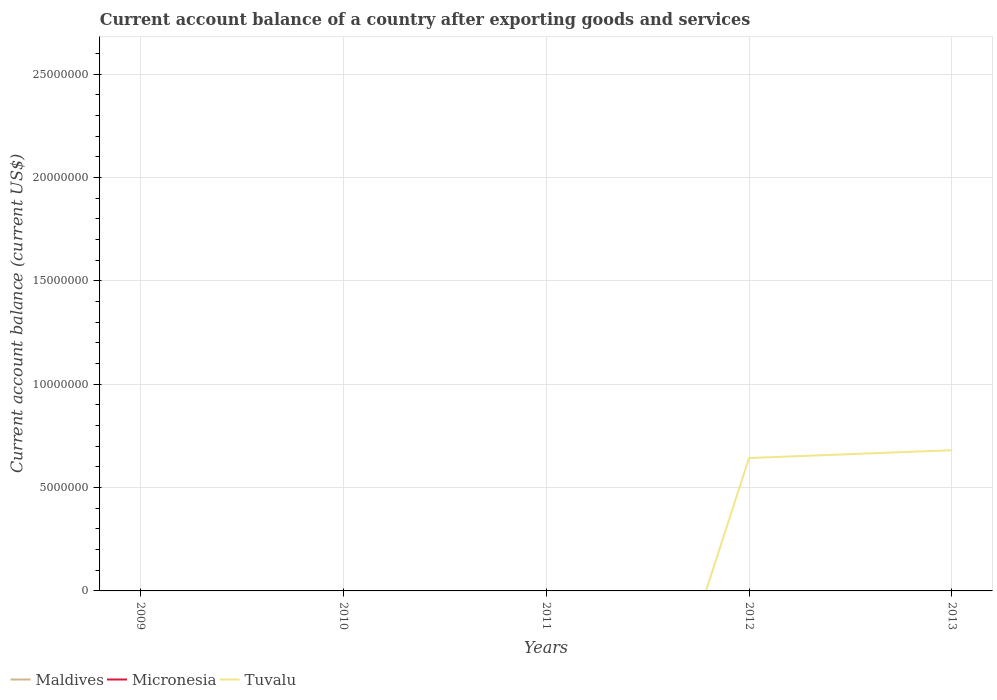What is the difference between the highest and the second highest account balance in Tuvalu?
Your answer should be compact. 6.81e+06. Is the account balance in Tuvalu strictly greater than the account balance in Maldives over the years?
Offer a terse response. No. How many lines are there?
Offer a very short reply. 1. Are the values on the major ticks of Y-axis written in scientific E-notation?
Your answer should be compact. No. Does the graph contain any zero values?
Your response must be concise. Yes. Does the graph contain grids?
Offer a very short reply. Yes. How are the legend labels stacked?
Offer a terse response. Horizontal. What is the title of the graph?
Keep it short and to the point. Current account balance of a country after exporting goods and services. Does "Cameroon" appear as one of the legend labels in the graph?
Your answer should be very brief. No. What is the label or title of the X-axis?
Your answer should be compact. Years. What is the label or title of the Y-axis?
Offer a terse response. Current account balance (current US$). What is the Current account balance (current US$) in Maldives in 2009?
Your response must be concise. 0. What is the Current account balance (current US$) of Micronesia in 2009?
Offer a very short reply. 0. What is the Current account balance (current US$) of Maldives in 2010?
Make the answer very short. 0. What is the Current account balance (current US$) in Maldives in 2011?
Provide a succinct answer. 0. What is the Current account balance (current US$) in Tuvalu in 2011?
Your answer should be very brief. 0. What is the Current account balance (current US$) of Micronesia in 2012?
Ensure brevity in your answer.  0. What is the Current account balance (current US$) of Tuvalu in 2012?
Offer a terse response. 6.43e+06. What is the Current account balance (current US$) of Maldives in 2013?
Your response must be concise. 0. What is the Current account balance (current US$) in Micronesia in 2013?
Make the answer very short. 0. What is the Current account balance (current US$) in Tuvalu in 2013?
Your response must be concise. 6.81e+06. Across all years, what is the maximum Current account balance (current US$) in Tuvalu?
Your answer should be very brief. 6.81e+06. Across all years, what is the minimum Current account balance (current US$) of Tuvalu?
Offer a very short reply. 0. What is the total Current account balance (current US$) in Tuvalu in the graph?
Offer a very short reply. 1.32e+07. What is the difference between the Current account balance (current US$) in Tuvalu in 2012 and that in 2013?
Keep it short and to the point. -3.80e+05. What is the average Current account balance (current US$) of Micronesia per year?
Keep it short and to the point. 0. What is the average Current account balance (current US$) in Tuvalu per year?
Make the answer very short. 2.65e+06. What is the ratio of the Current account balance (current US$) of Tuvalu in 2012 to that in 2013?
Your answer should be very brief. 0.94. What is the difference between the highest and the lowest Current account balance (current US$) in Tuvalu?
Your answer should be very brief. 6.81e+06. 